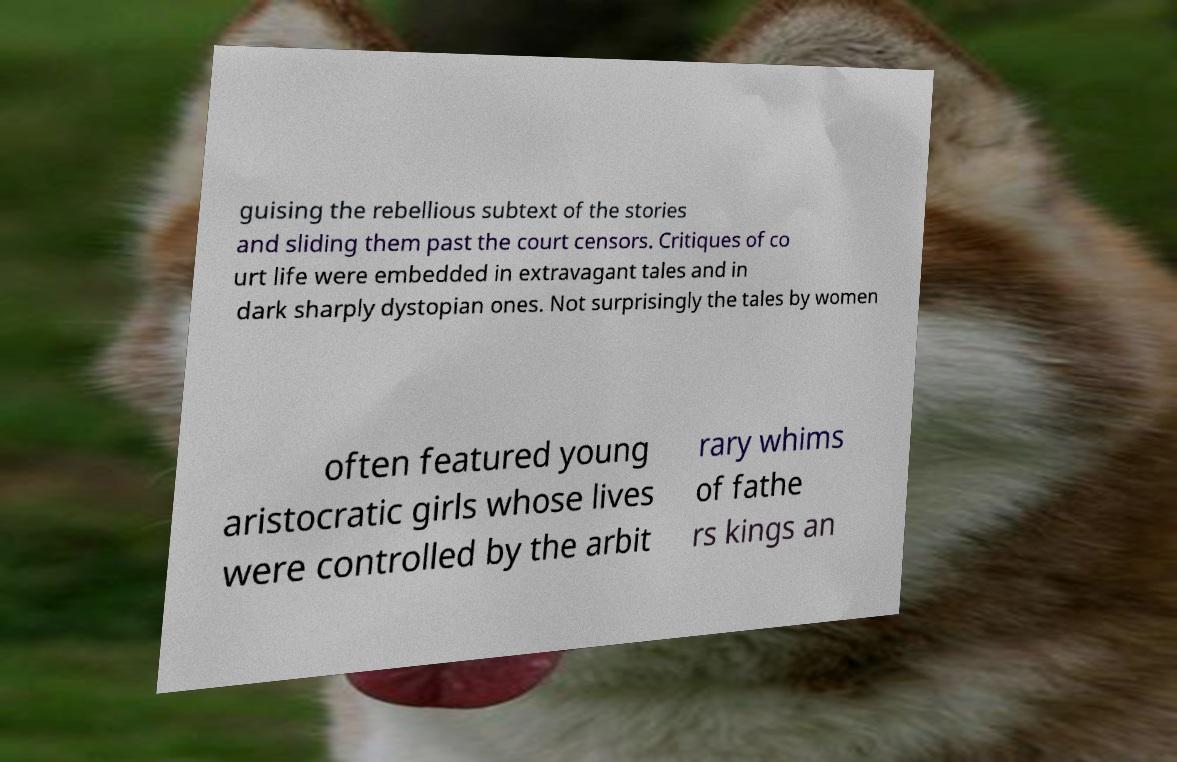Please identify and transcribe the text found in this image. guising the rebellious subtext of the stories and sliding them past the court censors. Critiques of co urt life were embedded in extravagant tales and in dark sharply dystopian ones. Not surprisingly the tales by women often featured young aristocratic girls whose lives were controlled by the arbit rary whims of fathe rs kings an 